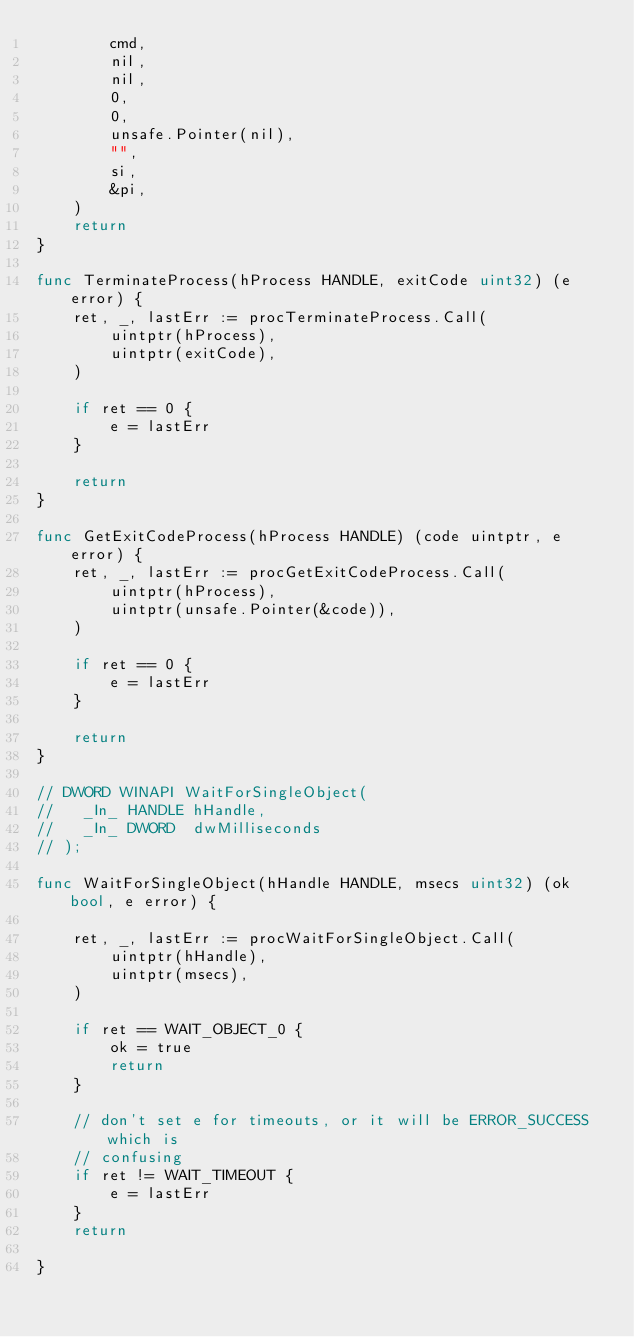<code> <loc_0><loc_0><loc_500><loc_500><_Go_>		cmd,
		nil,
		nil,
		0,
		0,
		unsafe.Pointer(nil),
		"",
		si,
		&pi,
	)
	return
}

func TerminateProcess(hProcess HANDLE, exitCode uint32) (e error) {
	ret, _, lastErr := procTerminateProcess.Call(
		uintptr(hProcess),
		uintptr(exitCode),
	)

	if ret == 0 {
		e = lastErr
	}

	return
}

func GetExitCodeProcess(hProcess HANDLE) (code uintptr, e error) {
	ret, _, lastErr := procGetExitCodeProcess.Call(
		uintptr(hProcess),
		uintptr(unsafe.Pointer(&code)),
	)

	if ret == 0 {
		e = lastErr
	}

	return
}

// DWORD WINAPI WaitForSingleObject(
//   _In_ HANDLE hHandle,
//   _In_ DWORD  dwMilliseconds
// );

func WaitForSingleObject(hHandle HANDLE, msecs uint32) (ok bool, e error) {

	ret, _, lastErr := procWaitForSingleObject.Call(
		uintptr(hHandle),
		uintptr(msecs),
	)

	if ret == WAIT_OBJECT_0 {
		ok = true
		return
	}

	// don't set e for timeouts, or it will be ERROR_SUCCESS which is
	// confusing
	if ret != WAIT_TIMEOUT {
		e = lastErr
	}
	return

}
</code> 